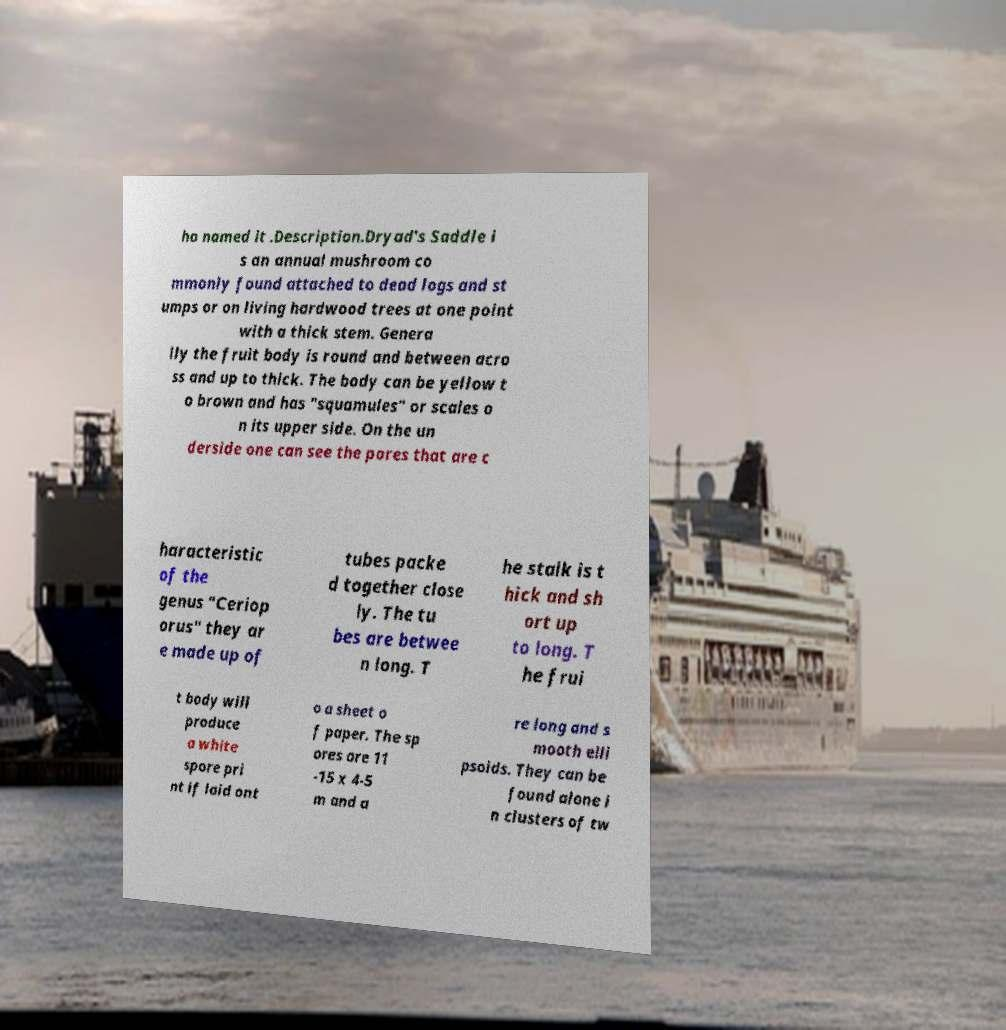I need the written content from this picture converted into text. Can you do that? ho named it .Description.Dryad's Saddle i s an annual mushroom co mmonly found attached to dead logs and st umps or on living hardwood trees at one point with a thick stem. Genera lly the fruit body is round and between acro ss and up to thick. The body can be yellow t o brown and has "squamules" or scales o n its upper side. On the un derside one can see the pores that are c haracteristic of the genus "Ceriop orus" they ar e made up of tubes packe d together close ly. The tu bes are betwee n long. T he stalk is t hick and sh ort up to long. T he frui t body will produce a white spore pri nt if laid ont o a sheet o f paper. The sp ores are 11 -15 x 4-5 m and a re long and s mooth elli psoids. They can be found alone i n clusters of tw 